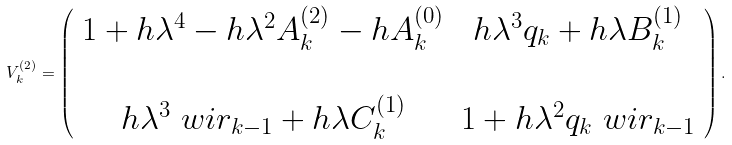<formula> <loc_0><loc_0><loc_500><loc_500>V _ { k } ^ { ( 2 ) } = \left ( \begin{array} { c c } 1 + h \lambda ^ { 4 } - h \lambda ^ { 2 } A _ { k } ^ { ( 2 ) } - h A _ { k } ^ { ( 0 ) } & h \lambda ^ { 3 } q _ { k } + h \lambda B _ { k } ^ { ( 1 ) } \\ \\ h \lambda ^ { 3 } \ w i r _ { k - 1 } + h \lambda C _ { k } ^ { ( 1 ) } & 1 + h \lambda ^ { 2 } q _ { k } \ w i r _ { k - 1 } \end{array} \right ) .</formula> 